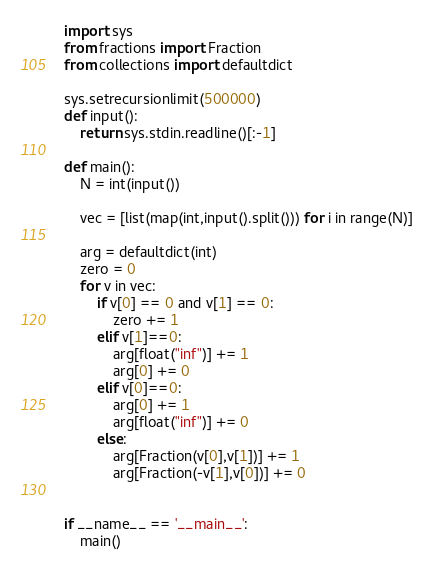<code> <loc_0><loc_0><loc_500><loc_500><_Python_>import sys
from fractions import Fraction
from collections import defaultdict

sys.setrecursionlimit(500000)
def input():
    return sys.stdin.readline()[:-1]

def main():
    N = int(input())

    vec = [list(map(int,input().split())) for i in range(N)]

    arg = defaultdict(int)
    zero = 0
    for v in vec:
        if v[0] == 0 and v[1] == 0:
            zero += 1
        elif v[1]==0:
            arg[float("inf")] += 1
            arg[0] += 0
        elif v[0]==0:
            arg[0] += 1
            arg[float("inf")] += 0
        else:
            arg[Fraction(v[0],v[1])] += 1
            arg[Fraction(-v[1],v[0])] += 0


if __name__ == '__main__':
    main()



</code> 